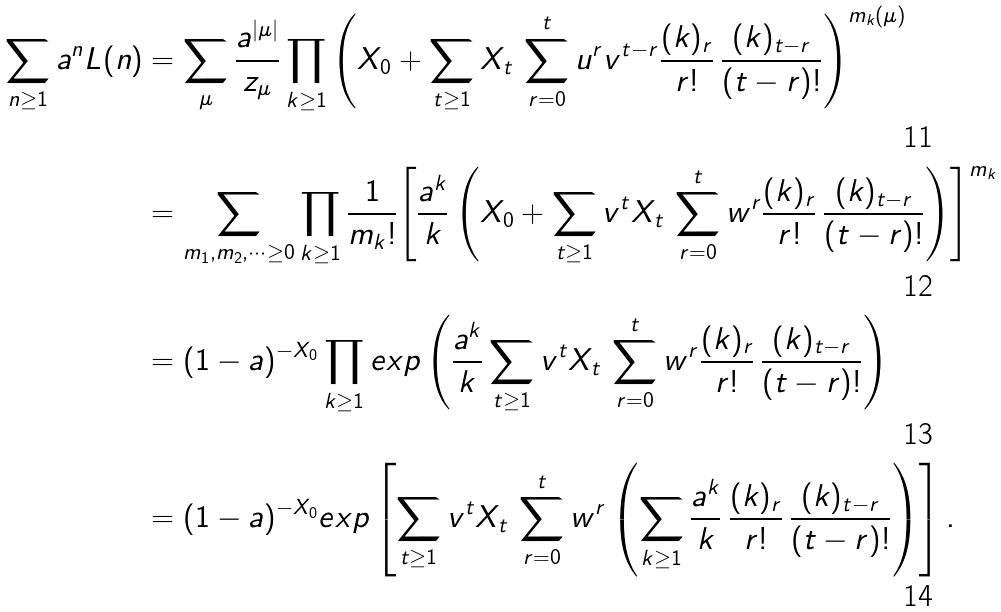Convert formula to latex. <formula><loc_0><loc_0><loc_500><loc_500>\sum _ { n \geq 1 } a ^ { n } L ( n ) & = \sum _ { \mu } \frac { a ^ { | \mu | } } { z _ { \mu } } \prod _ { k \geq 1 } { \left ( X _ { 0 } + \sum _ { t \geq 1 } X _ { t } \, \sum _ { r = 0 } ^ { t } u ^ { r } v ^ { t - r } \frac { ( k ) _ { r } } { r ! } \, \frac { ( k ) _ { t - r } } { ( t - r ) ! } \right ) } ^ { m _ { k } ( \mu ) } \\ & = \sum _ { m _ { 1 } , m _ { 2 } , \dots \geq 0 } \prod _ { k \geq 1 } \frac { 1 } { m _ { k } ! } { \left [ \frac { a ^ { k } } { k } \left ( X _ { 0 } + \sum _ { t \geq 1 } v ^ { t } X _ { t } \, \sum _ { r = 0 } ^ { t } w ^ { r } \frac { ( k ) _ { r } } { r ! } \, \frac { ( k ) _ { t - r } } { ( t - r ) ! } \right ) \right ] } ^ { m _ { k } } \\ & = ( 1 - a ) ^ { - X _ { 0 } } \prod _ { k \geq 1 } e x p \left ( \frac { a ^ { k } } { k } \sum _ { t \geq 1 } v ^ { t } X _ { t } \, \sum _ { r = 0 } ^ { t } w ^ { r } \frac { ( k ) _ { r } } { r ! } \, \frac { ( k ) _ { t - r } } { ( t - r ) ! } \right ) \\ & = ( 1 - a ) ^ { - X _ { 0 } } e x p \left [ \sum _ { t \geq 1 } v ^ { t } X _ { t } \, \sum _ { r = 0 } ^ { t } w ^ { r } \left ( \sum _ { k \geq 1 } \frac { a ^ { k } } { k } \, \frac { ( k ) _ { r } } { r ! } \, \frac { ( k ) _ { t - r } } { ( t - r ) ! } \right ) \right ] .</formula> 